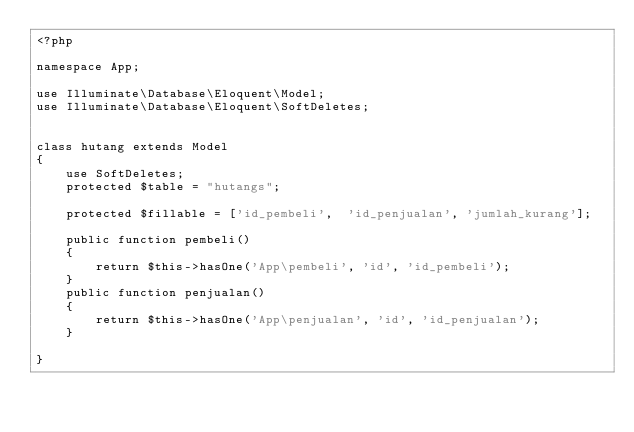<code> <loc_0><loc_0><loc_500><loc_500><_PHP_><?php

namespace App;

use Illuminate\Database\Eloquent\Model;
use Illuminate\Database\Eloquent\SoftDeletes;


class hutang extends Model
{
    use SoftDeletes;
    protected $table = "hutangs";

    protected $fillable = ['id_pembeli',  'id_penjualan', 'jumlah_kurang'];

    public function pembeli()
    {
        return $this->hasOne('App\pembeli', 'id', 'id_pembeli');
    }
    public function penjualan()
    {
        return $this->hasOne('App\penjualan', 'id', 'id_penjualan');
    }

}
</code> 